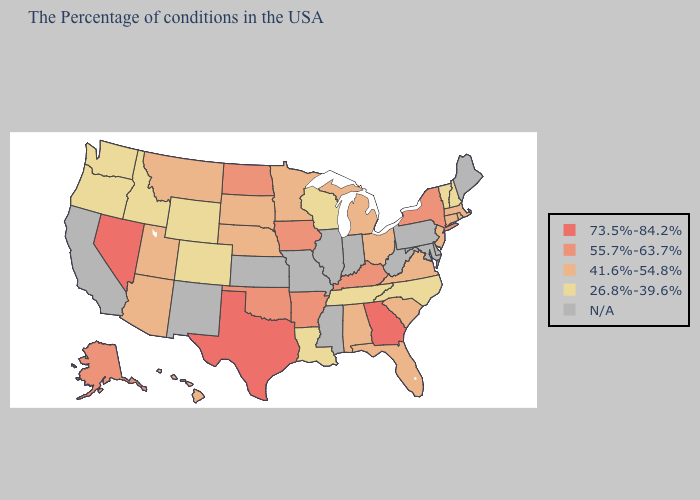Name the states that have a value in the range N/A?
Write a very short answer. Maine, Delaware, Maryland, Pennsylvania, West Virginia, Indiana, Illinois, Mississippi, Missouri, Kansas, New Mexico, California. Among the states that border Michigan , does Wisconsin have the highest value?
Keep it brief. No. What is the value of Arizona?
Answer briefly. 41.6%-54.8%. Does New Hampshire have the lowest value in the Northeast?
Be succinct. Yes. What is the highest value in states that border Connecticut?
Quick response, please. 55.7%-63.7%. Name the states that have a value in the range 41.6%-54.8%?
Write a very short answer. Massachusetts, Rhode Island, Connecticut, New Jersey, Virginia, South Carolina, Ohio, Florida, Michigan, Alabama, Minnesota, Nebraska, South Dakota, Utah, Montana, Arizona, Hawaii. Does Nevada have the highest value in the West?
Answer briefly. Yes. What is the lowest value in the South?
Short answer required. 26.8%-39.6%. Which states hav the highest value in the South?
Be succinct. Georgia, Texas. What is the lowest value in the USA?
Quick response, please. 26.8%-39.6%. What is the value of California?
Write a very short answer. N/A. Among the states that border Maine , which have the highest value?
Be succinct. New Hampshire. Does the map have missing data?
Keep it brief. Yes. What is the value of Colorado?
Keep it brief. 26.8%-39.6%. How many symbols are there in the legend?
Answer briefly. 5. 